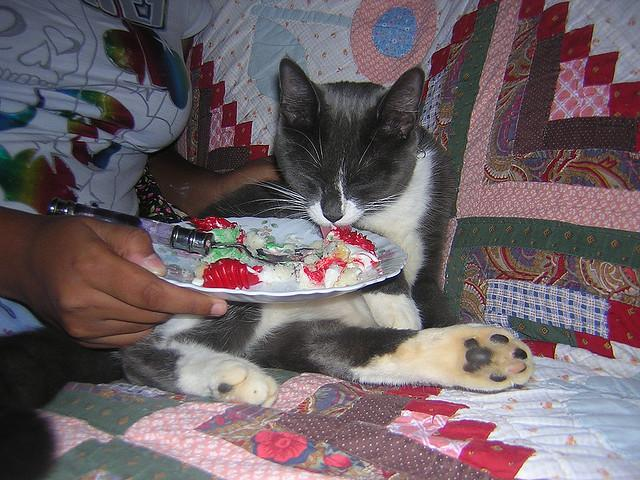How many toes does cats are supposed to have? four 